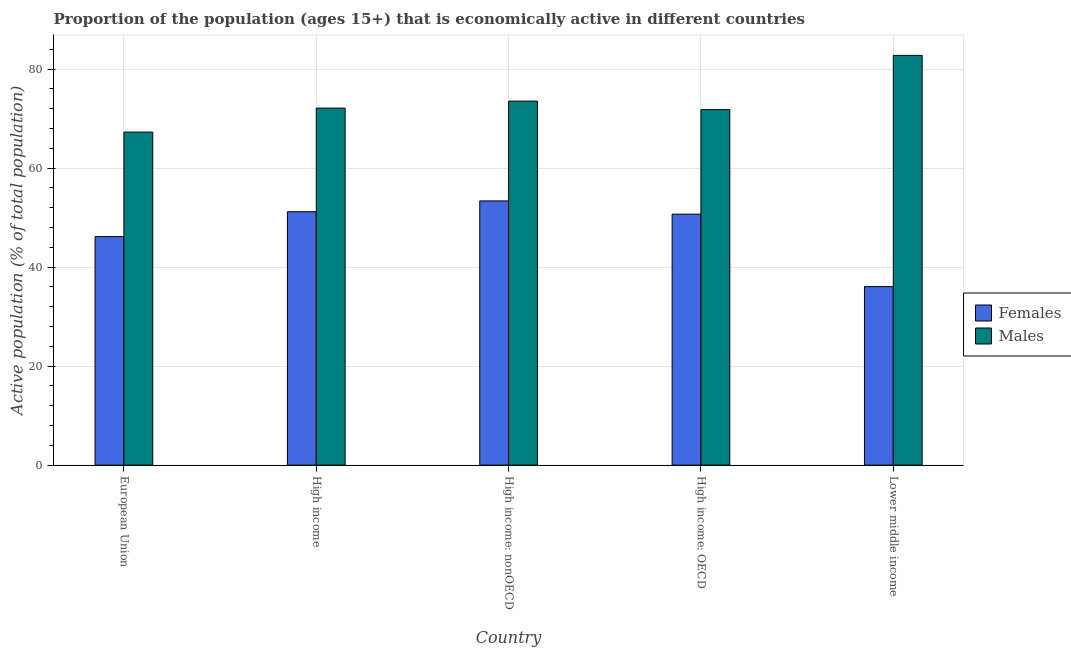How many different coloured bars are there?
Provide a short and direct response. 2. How many groups of bars are there?
Your response must be concise. 5. Are the number of bars per tick equal to the number of legend labels?
Your answer should be very brief. Yes. Are the number of bars on each tick of the X-axis equal?
Your response must be concise. Yes. How many bars are there on the 3rd tick from the left?
Provide a short and direct response. 2. How many bars are there on the 2nd tick from the right?
Offer a terse response. 2. What is the label of the 4th group of bars from the left?
Your answer should be compact. High income: OECD. In how many cases, is the number of bars for a given country not equal to the number of legend labels?
Provide a short and direct response. 0. What is the percentage of economically active male population in High income?
Give a very brief answer. 72.14. Across all countries, what is the maximum percentage of economically active male population?
Your answer should be compact. 82.79. Across all countries, what is the minimum percentage of economically active female population?
Your answer should be very brief. 36.08. In which country was the percentage of economically active male population maximum?
Ensure brevity in your answer.  Lower middle income. In which country was the percentage of economically active male population minimum?
Your answer should be very brief. European Union. What is the total percentage of economically active male population in the graph?
Ensure brevity in your answer.  367.61. What is the difference between the percentage of economically active female population in High income and that in Lower middle income?
Your response must be concise. 15.13. What is the difference between the percentage of economically active female population in High income: nonOECD and the percentage of economically active male population in High income?
Your response must be concise. -18.75. What is the average percentage of economically active female population per country?
Your answer should be very brief. 47.51. What is the difference between the percentage of economically active male population and percentage of economically active female population in High income: nonOECD?
Your answer should be very brief. 20.16. What is the ratio of the percentage of economically active female population in European Union to that in High income?
Ensure brevity in your answer.  0.9. What is the difference between the highest and the second highest percentage of economically active female population?
Your response must be concise. 2.18. What is the difference between the highest and the lowest percentage of economically active female population?
Offer a very short reply. 17.31. Is the sum of the percentage of economically active male population in European Union and Lower middle income greater than the maximum percentage of economically active female population across all countries?
Keep it short and to the point. Yes. What does the 2nd bar from the left in European Union represents?
Your answer should be compact. Males. What does the 1st bar from the right in European Union represents?
Ensure brevity in your answer.  Males. How many bars are there?
Provide a succinct answer. 10. Are all the bars in the graph horizontal?
Provide a short and direct response. No. How many countries are there in the graph?
Your answer should be compact. 5. Are the values on the major ticks of Y-axis written in scientific E-notation?
Your answer should be very brief. No. Does the graph contain grids?
Give a very brief answer. Yes. Where does the legend appear in the graph?
Provide a succinct answer. Center right. How many legend labels are there?
Your answer should be very brief. 2. How are the legend labels stacked?
Keep it short and to the point. Vertical. What is the title of the graph?
Your answer should be very brief. Proportion of the population (ages 15+) that is economically active in different countries. Does "Start a business" appear as one of the legend labels in the graph?
Provide a short and direct response. No. What is the label or title of the X-axis?
Offer a terse response. Country. What is the label or title of the Y-axis?
Keep it short and to the point. Active population (% of total population). What is the Active population (% of total population) of Females in European Union?
Offer a very short reply. 46.18. What is the Active population (% of total population) of Males in European Union?
Ensure brevity in your answer.  67.29. What is the Active population (% of total population) of Females in High income?
Your answer should be compact. 51.2. What is the Active population (% of total population) of Males in High income?
Offer a very short reply. 72.14. What is the Active population (% of total population) in Females in High income: nonOECD?
Provide a short and direct response. 53.39. What is the Active population (% of total population) of Males in High income: nonOECD?
Ensure brevity in your answer.  73.55. What is the Active population (% of total population) of Females in High income: OECD?
Ensure brevity in your answer.  50.71. What is the Active population (% of total population) in Males in High income: OECD?
Give a very brief answer. 71.84. What is the Active population (% of total population) of Females in Lower middle income?
Provide a short and direct response. 36.08. What is the Active population (% of total population) of Males in Lower middle income?
Ensure brevity in your answer.  82.79. Across all countries, what is the maximum Active population (% of total population) of Females?
Provide a short and direct response. 53.39. Across all countries, what is the maximum Active population (% of total population) in Males?
Your answer should be very brief. 82.79. Across all countries, what is the minimum Active population (% of total population) of Females?
Give a very brief answer. 36.08. Across all countries, what is the minimum Active population (% of total population) of Males?
Your answer should be very brief. 67.29. What is the total Active population (% of total population) in Females in the graph?
Your answer should be compact. 237.56. What is the total Active population (% of total population) in Males in the graph?
Provide a short and direct response. 367.61. What is the difference between the Active population (% of total population) of Females in European Union and that in High income?
Make the answer very short. -5.03. What is the difference between the Active population (% of total population) in Males in European Union and that in High income?
Provide a short and direct response. -4.84. What is the difference between the Active population (% of total population) of Females in European Union and that in High income: nonOECD?
Your response must be concise. -7.21. What is the difference between the Active population (% of total population) in Males in European Union and that in High income: nonOECD?
Ensure brevity in your answer.  -6.26. What is the difference between the Active population (% of total population) in Females in European Union and that in High income: OECD?
Your answer should be compact. -4.53. What is the difference between the Active population (% of total population) in Males in European Union and that in High income: OECD?
Offer a very short reply. -4.55. What is the difference between the Active population (% of total population) of Females in European Union and that in Lower middle income?
Offer a very short reply. 10.1. What is the difference between the Active population (% of total population) of Males in European Union and that in Lower middle income?
Give a very brief answer. -15.5. What is the difference between the Active population (% of total population) of Females in High income and that in High income: nonOECD?
Offer a very short reply. -2.18. What is the difference between the Active population (% of total population) in Males in High income and that in High income: nonOECD?
Your answer should be very brief. -1.41. What is the difference between the Active population (% of total population) in Females in High income and that in High income: OECD?
Ensure brevity in your answer.  0.49. What is the difference between the Active population (% of total population) in Males in High income and that in High income: OECD?
Ensure brevity in your answer.  0.3. What is the difference between the Active population (% of total population) in Females in High income and that in Lower middle income?
Provide a succinct answer. 15.13. What is the difference between the Active population (% of total population) in Males in High income and that in Lower middle income?
Keep it short and to the point. -10.66. What is the difference between the Active population (% of total population) of Females in High income: nonOECD and that in High income: OECD?
Offer a very short reply. 2.68. What is the difference between the Active population (% of total population) of Males in High income: nonOECD and that in High income: OECD?
Give a very brief answer. 1.71. What is the difference between the Active population (% of total population) of Females in High income: nonOECD and that in Lower middle income?
Give a very brief answer. 17.31. What is the difference between the Active population (% of total population) of Males in High income: nonOECD and that in Lower middle income?
Provide a succinct answer. -9.24. What is the difference between the Active population (% of total population) of Females in High income: OECD and that in Lower middle income?
Make the answer very short. 14.64. What is the difference between the Active population (% of total population) in Males in High income: OECD and that in Lower middle income?
Provide a short and direct response. -10.95. What is the difference between the Active population (% of total population) in Females in European Union and the Active population (% of total population) in Males in High income?
Offer a terse response. -25.96. What is the difference between the Active population (% of total population) in Females in European Union and the Active population (% of total population) in Males in High income: nonOECD?
Provide a short and direct response. -27.37. What is the difference between the Active population (% of total population) of Females in European Union and the Active population (% of total population) of Males in High income: OECD?
Offer a very short reply. -25.66. What is the difference between the Active population (% of total population) of Females in European Union and the Active population (% of total population) of Males in Lower middle income?
Your answer should be compact. -36.62. What is the difference between the Active population (% of total population) in Females in High income and the Active population (% of total population) in Males in High income: nonOECD?
Give a very brief answer. -22.35. What is the difference between the Active population (% of total population) in Females in High income and the Active population (% of total population) in Males in High income: OECD?
Make the answer very short. -20.64. What is the difference between the Active population (% of total population) in Females in High income and the Active population (% of total population) in Males in Lower middle income?
Make the answer very short. -31.59. What is the difference between the Active population (% of total population) of Females in High income: nonOECD and the Active population (% of total population) of Males in High income: OECD?
Provide a short and direct response. -18.45. What is the difference between the Active population (% of total population) of Females in High income: nonOECD and the Active population (% of total population) of Males in Lower middle income?
Keep it short and to the point. -29.41. What is the difference between the Active population (% of total population) of Females in High income: OECD and the Active population (% of total population) of Males in Lower middle income?
Offer a very short reply. -32.08. What is the average Active population (% of total population) in Females per country?
Offer a terse response. 47.51. What is the average Active population (% of total population) of Males per country?
Give a very brief answer. 73.52. What is the difference between the Active population (% of total population) in Females and Active population (% of total population) in Males in European Union?
Your answer should be very brief. -21.11. What is the difference between the Active population (% of total population) of Females and Active population (% of total population) of Males in High income?
Give a very brief answer. -20.93. What is the difference between the Active population (% of total population) in Females and Active population (% of total population) in Males in High income: nonOECD?
Your response must be concise. -20.16. What is the difference between the Active population (% of total population) in Females and Active population (% of total population) in Males in High income: OECD?
Your response must be concise. -21.13. What is the difference between the Active population (% of total population) in Females and Active population (% of total population) in Males in Lower middle income?
Offer a very short reply. -46.72. What is the ratio of the Active population (% of total population) of Females in European Union to that in High income?
Provide a short and direct response. 0.9. What is the ratio of the Active population (% of total population) in Males in European Union to that in High income?
Offer a terse response. 0.93. What is the ratio of the Active population (% of total population) in Females in European Union to that in High income: nonOECD?
Offer a very short reply. 0.86. What is the ratio of the Active population (% of total population) in Males in European Union to that in High income: nonOECD?
Make the answer very short. 0.91. What is the ratio of the Active population (% of total population) in Females in European Union to that in High income: OECD?
Your answer should be compact. 0.91. What is the ratio of the Active population (% of total population) in Males in European Union to that in High income: OECD?
Provide a succinct answer. 0.94. What is the ratio of the Active population (% of total population) of Females in European Union to that in Lower middle income?
Provide a short and direct response. 1.28. What is the ratio of the Active population (% of total population) of Males in European Union to that in Lower middle income?
Give a very brief answer. 0.81. What is the ratio of the Active population (% of total population) in Females in High income to that in High income: nonOECD?
Your response must be concise. 0.96. What is the ratio of the Active population (% of total population) of Males in High income to that in High income: nonOECD?
Your answer should be compact. 0.98. What is the ratio of the Active population (% of total population) of Females in High income to that in High income: OECD?
Give a very brief answer. 1.01. What is the ratio of the Active population (% of total population) in Females in High income to that in Lower middle income?
Keep it short and to the point. 1.42. What is the ratio of the Active population (% of total population) of Males in High income to that in Lower middle income?
Offer a very short reply. 0.87. What is the ratio of the Active population (% of total population) in Females in High income: nonOECD to that in High income: OECD?
Offer a very short reply. 1.05. What is the ratio of the Active population (% of total population) of Males in High income: nonOECD to that in High income: OECD?
Provide a succinct answer. 1.02. What is the ratio of the Active population (% of total population) in Females in High income: nonOECD to that in Lower middle income?
Provide a succinct answer. 1.48. What is the ratio of the Active population (% of total population) in Males in High income: nonOECD to that in Lower middle income?
Make the answer very short. 0.89. What is the ratio of the Active population (% of total population) in Females in High income: OECD to that in Lower middle income?
Make the answer very short. 1.41. What is the ratio of the Active population (% of total population) of Males in High income: OECD to that in Lower middle income?
Provide a short and direct response. 0.87. What is the difference between the highest and the second highest Active population (% of total population) of Females?
Your answer should be compact. 2.18. What is the difference between the highest and the second highest Active population (% of total population) in Males?
Offer a very short reply. 9.24. What is the difference between the highest and the lowest Active population (% of total population) of Females?
Provide a short and direct response. 17.31. What is the difference between the highest and the lowest Active population (% of total population) of Males?
Your response must be concise. 15.5. 